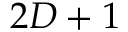<formula> <loc_0><loc_0><loc_500><loc_500>2 D + 1</formula> 